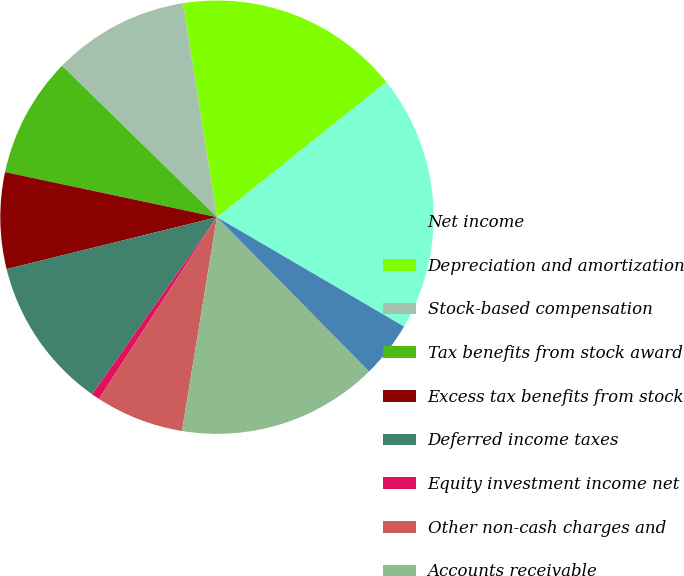<chart> <loc_0><loc_0><loc_500><loc_500><pie_chart><fcel>Net income<fcel>Depreciation and amortization<fcel>Stock-based compensation<fcel>Tax benefits from stock award<fcel>Excess tax benefits from stock<fcel>Deferred income taxes<fcel>Equity investment income net<fcel>Other non-cash charges and<fcel>Accounts receivable<fcel>Inventories<nl><fcel>19.16%<fcel>16.77%<fcel>10.18%<fcel>8.98%<fcel>7.19%<fcel>11.38%<fcel>0.6%<fcel>6.59%<fcel>14.97%<fcel>4.19%<nl></chart> 